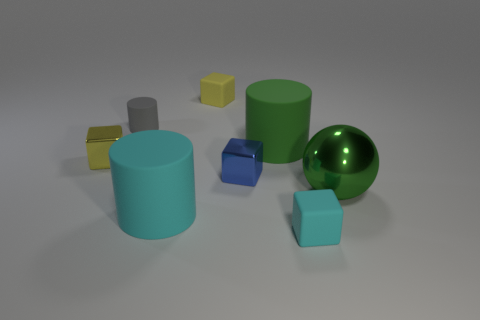What number of objects have the same color as the large metallic sphere?
Ensure brevity in your answer.  1. There is a ball; is it the same color as the matte cylinder that is to the right of the yellow rubber object?
Offer a very short reply. Yes. What is the size of the green thing left of the metallic ball?
Provide a short and direct response. Large. Is the size of the yellow rubber thing the same as the green rubber thing?
Give a very brief answer. No. Is the number of cubes to the left of the large cyan rubber thing less than the number of blocks in front of the yellow rubber thing?
Ensure brevity in your answer.  Yes. What size is the block that is on the left side of the small blue metal object and in front of the tiny yellow rubber thing?
Your answer should be compact. Small. There is a cyan matte thing to the right of the small yellow thing that is on the right side of the large cyan matte object; is there a large object to the left of it?
Give a very brief answer. Yes. Is there a large blue metallic ball?
Provide a succinct answer. No. Are there more tiny blue blocks that are on the right side of the cyan block than rubber things to the right of the large green metallic thing?
Make the answer very short. No. What is the size of the other cube that is made of the same material as the blue cube?
Ensure brevity in your answer.  Small. 